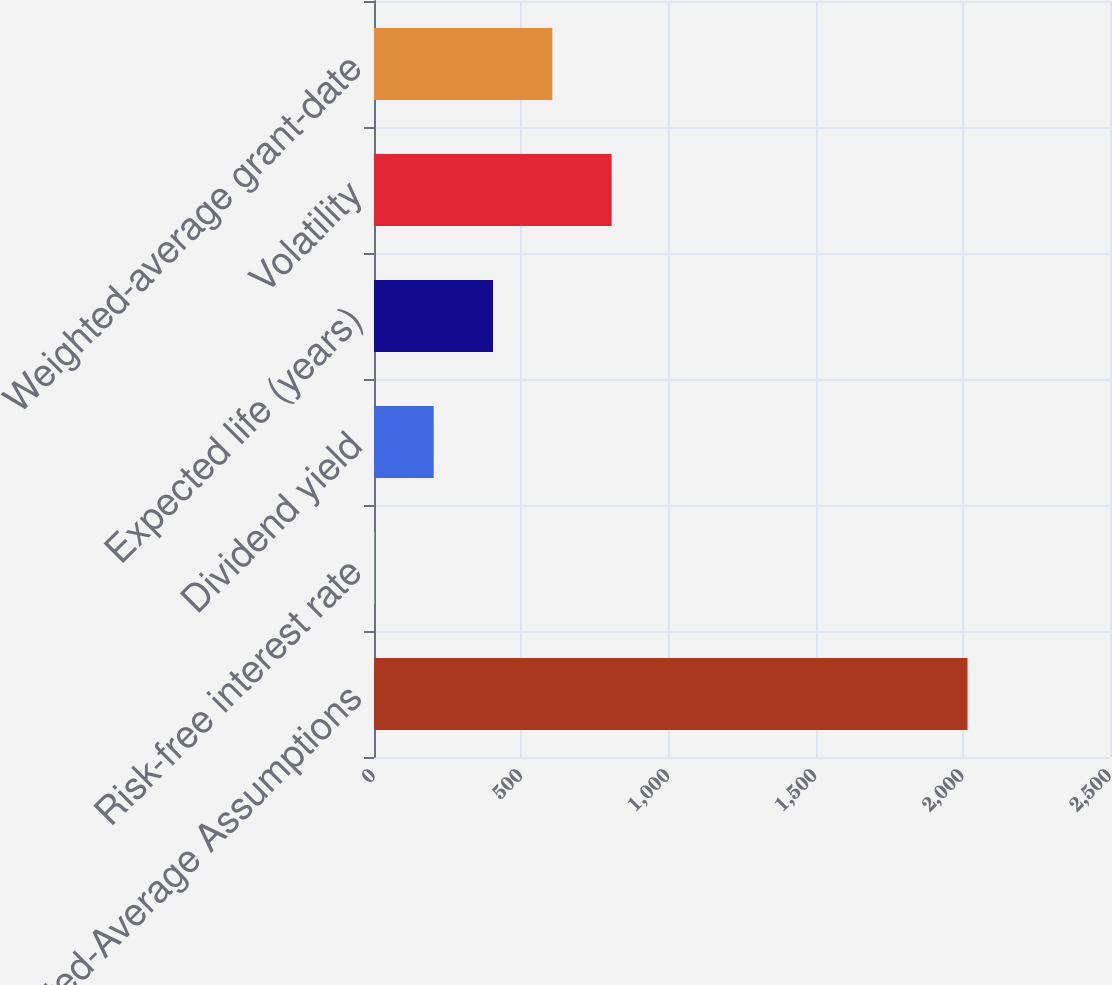<chart> <loc_0><loc_0><loc_500><loc_500><bar_chart><fcel>Weighted-Average Assumptions<fcel>Risk-free interest rate<fcel>Dividend yield<fcel>Expected life (years)<fcel>Volatility<fcel>Weighted-average grant-date<nl><fcel>2016<fcel>1.3<fcel>202.77<fcel>404.24<fcel>807.18<fcel>605.71<nl></chart> 